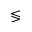Convert formula to latex. <formula><loc_0><loc_0><loc_500><loc_500>\leq s s g t r</formula> 